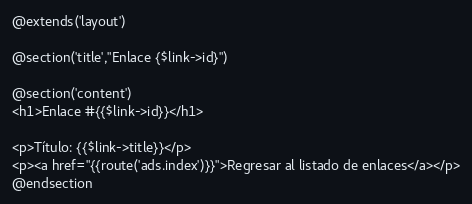<code> <loc_0><loc_0><loc_500><loc_500><_PHP_>@extends('layout')

@section('title',"Enlace {$link->id}")

@section('content')
<h1>Enlace #{{$link->id}}</h1>

<p>Título: {{$link->title}}</p>
<p><a href="{{route('ads.index')}}">Regresar al listado de enlaces</a></p>
@endsection</code> 